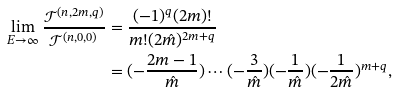Convert formula to latex. <formula><loc_0><loc_0><loc_500><loc_500>\lim _ { E \rightarrow \infty } \frac { \mathcal { T } ^ { ( n , 2 m , q ) } } { \mathcal { T } ^ { ( n , 0 , 0 ) } } & = \frac { ( - 1 ) ^ { q } ( 2 m ) ! } { m ! ( 2 \hat { m } ) ^ { 2 m + q } } \\ & = ( - \frac { 2 m - 1 } { \hat { m } } ) \cdots ( - \frac { 3 } { \hat { m } } ) ( - \frac { 1 } { \hat { m } } ) ( - \frac { 1 } { 2 \hat { m } } ) ^ { m + q } ,</formula> 